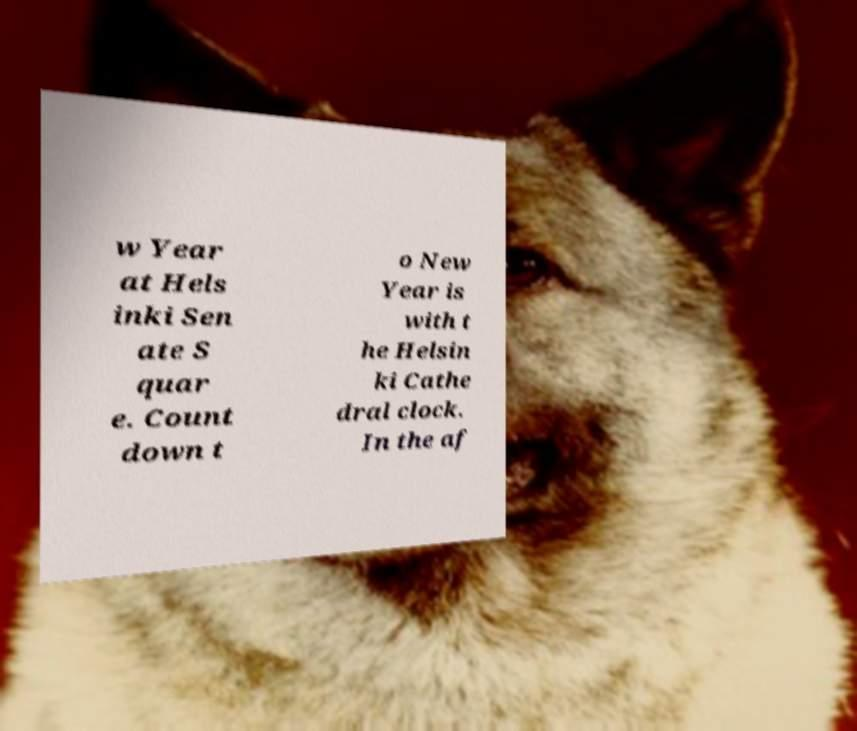For documentation purposes, I need the text within this image transcribed. Could you provide that? w Year at Hels inki Sen ate S quar e. Count down t o New Year is with t he Helsin ki Cathe dral clock. In the af 